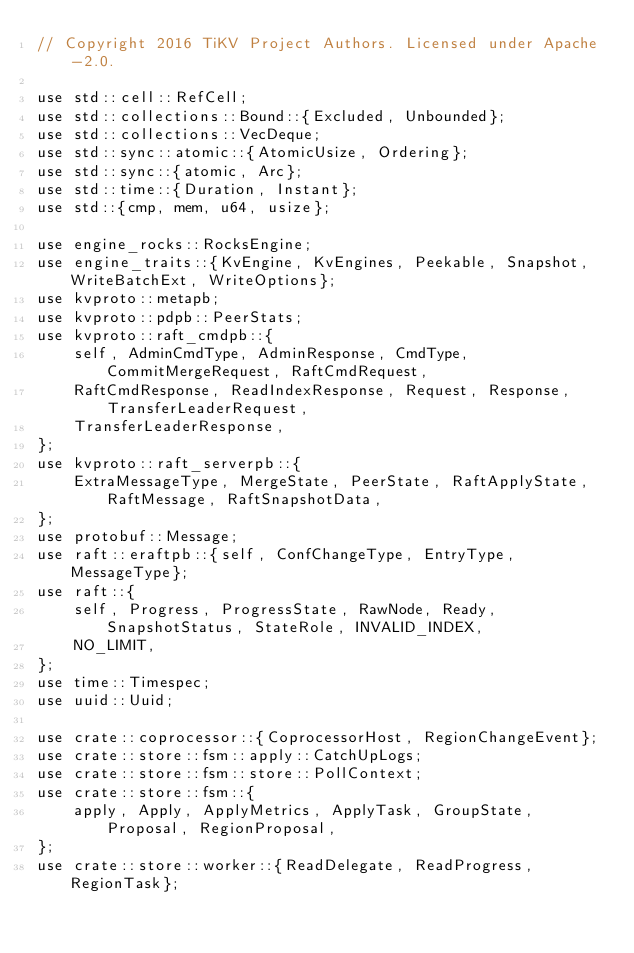Convert code to text. <code><loc_0><loc_0><loc_500><loc_500><_Rust_>// Copyright 2016 TiKV Project Authors. Licensed under Apache-2.0.

use std::cell::RefCell;
use std::collections::Bound::{Excluded, Unbounded};
use std::collections::VecDeque;
use std::sync::atomic::{AtomicUsize, Ordering};
use std::sync::{atomic, Arc};
use std::time::{Duration, Instant};
use std::{cmp, mem, u64, usize};

use engine_rocks::RocksEngine;
use engine_traits::{KvEngine, KvEngines, Peekable, Snapshot, WriteBatchExt, WriteOptions};
use kvproto::metapb;
use kvproto::pdpb::PeerStats;
use kvproto::raft_cmdpb::{
    self, AdminCmdType, AdminResponse, CmdType, CommitMergeRequest, RaftCmdRequest,
    RaftCmdResponse, ReadIndexResponse, Request, Response, TransferLeaderRequest,
    TransferLeaderResponse,
};
use kvproto::raft_serverpb::{
    ExtraMessageType, MergeState, PeerState, RaftApplyState, RaftMessage, RaftSnapshotData,
};
use protobuf::Message;
use raft::eraftpb::{self, ConfChangeType, EntryType, MessageType};
use raft::{
    self, Progress, ProgressState, RawNode, Ready, SnapshotStatus, StateRole, INVALID_INDEX,
    NO_LIMIT,
};
use time::Timespec;
use uuid::Uuid;

use crate::coprocessor::{CoprocessorHost, RegionChangeEvent};
use crate::store::fsm::apply::CatchUpLogs;
use crate::store::fsm::store::PollContext;
use crate::store::fsm::{
    apply, Apply, ApplyMetrics, ApplyTask, GroupState, Proposal, RegionProposal,
};
use crate::store::worker::{ReadDelegate, ReadProgress, RegionTask};</code> 